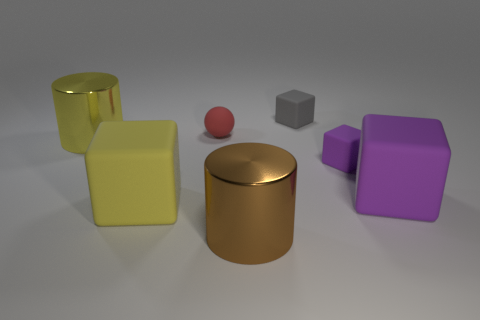The other big rubber object that is the same shape as the large purple object is what color?
Offer a terse response. Yellow. Is there another tiny ball that has the same color as the tiny rubber ball?
Your response must be concise. No. What size is the sphere that is made of the same material as the small purple cube?
Offer a very short reply. Small. Is there any other thing that is the same color as the matte ball?
Ensure brevity in your answer.  No. What color is the large matte cube to the right of the ball?
Keep it short and to the point. Purple. Is there a metallic thing that is behind the big yellow object that is behind the large matte object on the right side of the small gray rubber cube?
Offer a terse response. No. Is the number of small matte cubes to the left of the yellow metallic cylinder greater than the number of blocks?
Offer a terse response. No. Do the big matte object to the right of the tiny red ball and the gray thing have the same shape?
Provide a short and direct response. Yes. Is there any other thing that is made of the same material as the tiny red thing?
Your answer should be very brief. Yes. How many objects are big purple blocks or large matte things that are right of the red object?
Ensure brevity in your answer.  1. 